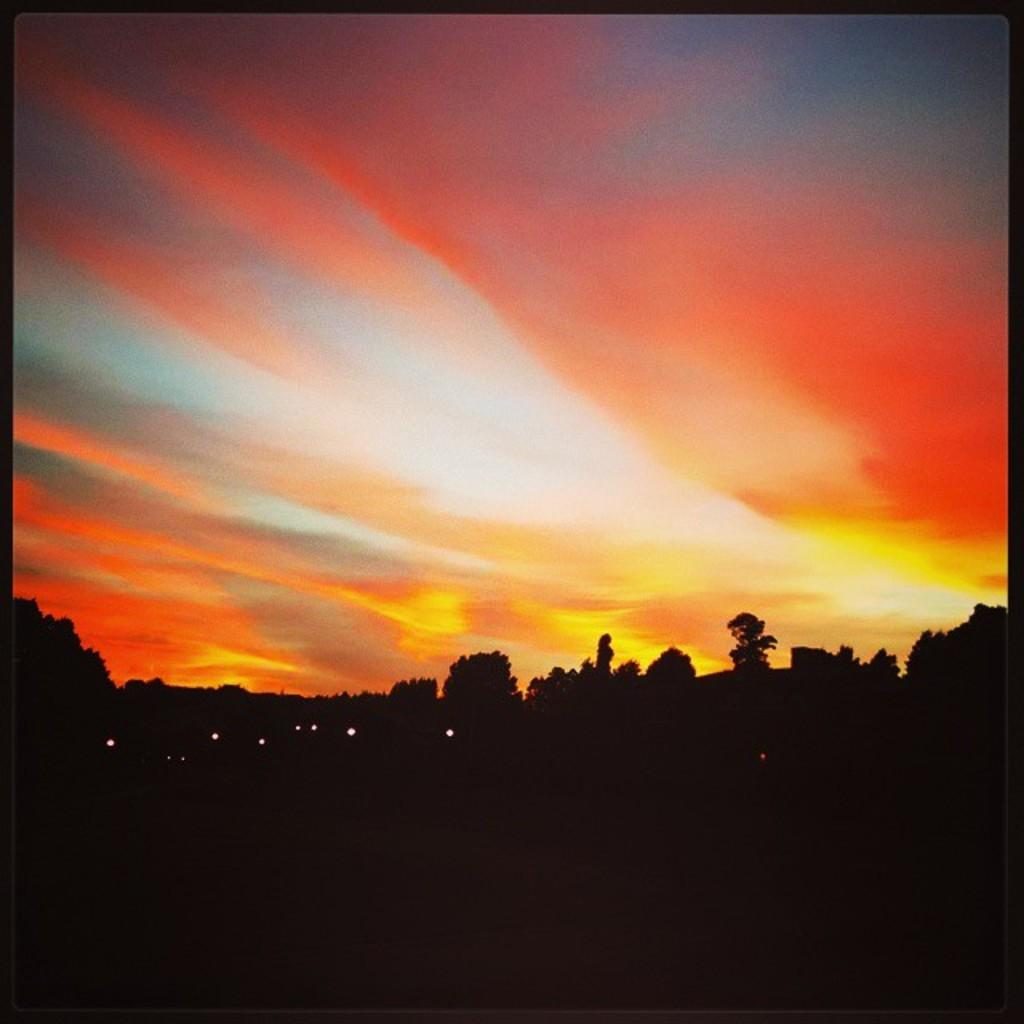What is the color of the bottom part of the image? The bottom of the image is dark. What type of natural elements can be seen in the image? Trees are visible in the image. What artificial elements can be seen in the image? Lights are visible in the image. What is visible at the top of the image? The sky is visible at the top of the image. What is your opinion on the island shown in the image? There is no island present in the image, so it is not possible to provide an opinion on it. 